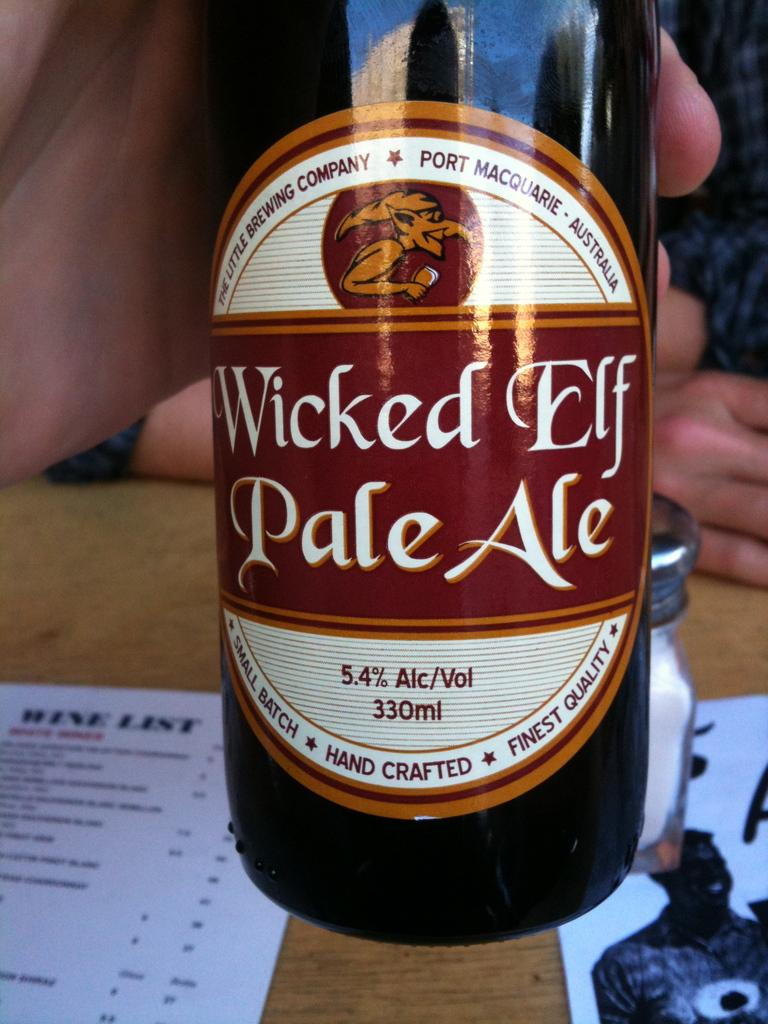Who or what is in the image? There is a person in the image. What is the person holding in their hand? The person's hand is holding a bottle. What can be seen on the wooden surface in the image? There are papers and a jar on the wooden surface. Can you describe the background of the image? There is another person visible in the background of the image. What type of stove is being used by the person in the image? There is no stove present in the image. How many legs does the person in the image have? The person in the image has two legs, but this question is irrelevant as it does not pertain to any detail in the image. 